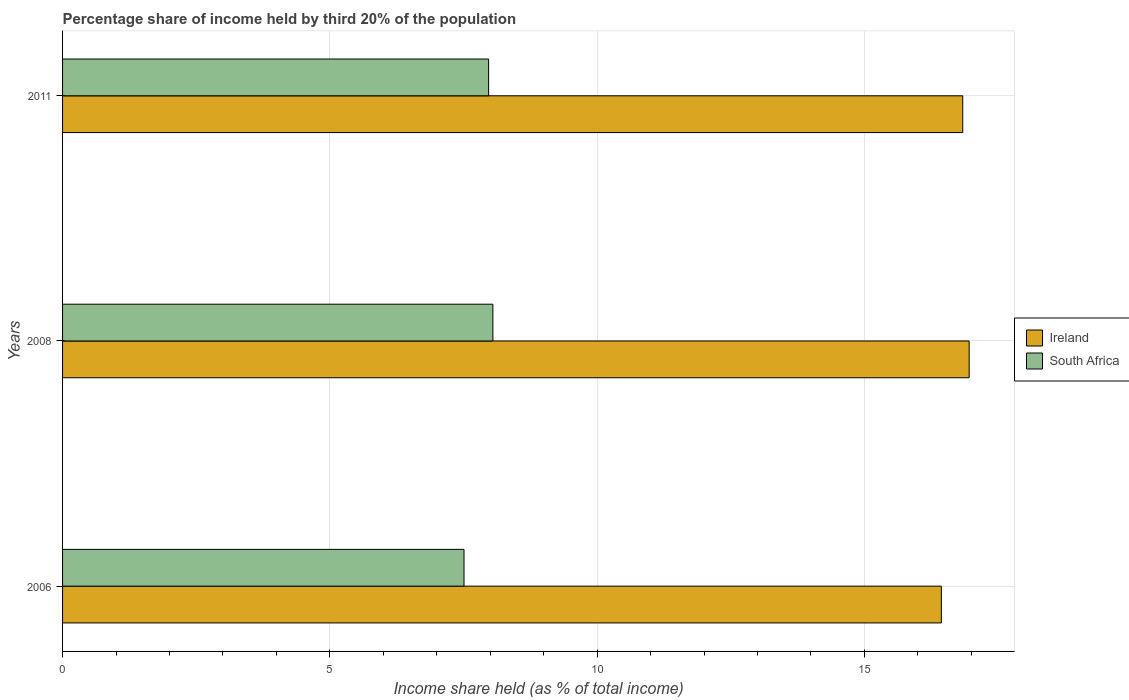How many bars are there on the 1st tick from the top?
Your answer should be compact. 2. How many bars are there on the 2nd tick from the bottom?
Your answer should be compact. 2. In how many cases, is the number of bars for a given year not equal to the number of legend labels?
Make the answer very short. 0. What is the share of income held by third 20% of the population in South Africa in 2008?
Give a very brief answer. 8.05. Across all years, what is the maximum share of income held by third 20% of the population in South Africa?
Keep it short and to the point. 8.05. Across all years, what is the minimum share of income held by third 20% of the population in Ireland?
Provide a succinct answer. 16.44. In which year was the share of income held by third 20% of the population in South Africa maximum?
Your answer should be very brief. 2008. In which year was the share of income held by third 20% of the population in Ireland minimum?
Ensure brevity in your answer.  2006. What is the total share of income held by third 20% of the population in South Africa in the graph?
Provide a succinct answer. 23.53. What is the difference between the share of income held by third 20% of the population in Ireland in 2008 and that in 2011?
Ensure brevity in your answer.  0.12. What is the difference between the share of income held by third 20% of the population in Ireland in 2006 and the share of income held by third 20% of the population in South Africa in 2008?
Your answer should be compact. 8.39. What is the average share of income held by third 20% of the population in South Africa per year?
Provide a succinct answer. 7.84. In the year 2008, what is the difference between the share of income held by third 20% of the population in South Africa and share of income held by third 20% of the population in Ireland?
Make the answer very short. -8.91. What is the ratio of the share of income held by third 20% of the population in Ireland in 2008 to that in 2011?
Make the answer very short. 1.01. What is the difference between the highest and the second highest share of income held by third 20% of the population in Ireland?
Offer a very short reply. 0.12. What is the difference between the highest and the lowest share of income held by third 20% of the population in Ireland?
Your answer should be compact. 0.52. What does the 1st bar from the top in 2006 represents?
Make the answer very short. South Africa. What does the 2nd bar from the bottom in 2008 represents?
Offer a terse response. South Africa. Where does the legend appear in the graph?
Offer a very short reply. Center right. How many legend labels are there?
Offer a terse response. 2. What is the title of the graph?
Offer a very short reply. Percentage share of income held by third 20% of the population. Does "Georgia" appear as one of the legend labels in the graph?
Your answer should be very brief. No. What is the label or title of the X-axis?
Provide a short and direct response. Income share held (as % of total income). What is the Income share held (as % of total income) of Ireland in 2006?
Your response must be concise. 16.44. What is the Income share held (as % of total income) of South Africa in 2006?
Give a very brief answer. 7.51. What is the Income share held (as % of total income) of Ireland in 2008?
Ensure brevity in your answer.  16.96. What is the Income share held (as % of total income) of South Africa in 2008?
Offer a very short reply. 8.05. What is the Income share held (as % of total income) in Ireland in 2011?
Give a very brief answer. 16.84. What is the Income share held (as % of total income) of South Africa in 2011?
Offer a terse response. 7.97. Across all years, what is the maximum Income share held (as % of total income) in Ireland?
Keep it short and to the point. 16.96. Across all years, what is the maximum Income share held (as % of total income) of South Africa?
Provide a short and direct response. 8.05. Across all years, what is the minimum Income share held (as % of total income) of Ireland?
Make the answer very short. 16.44. Across all years, what is the minimum Income share held (as % of total income) in South Africa?
Your answer should be very brief. 7.51. What is the total Income share held (as % of total income) in Ireland in the graph?
Your response must be concise. 50.24. What is the total Income share held (as % of total income) in South Africa in the graph?
Offer a very short reply. 23.53. What is the difference between the Income share held (as % of total income) in Ireland in 2006 and that in 2008?
Ensure brevity in your answer.  -0.52. What is the difference between the Income share held (as % of total income) of South Africa in 2006 and that in 2008?
Ensure brevity in your answer.  -0.54. What is the difference between the Income share held (as % of total income) of South Africa in 2006 and that in 2011?
Ensure brevity in your answer.  -0.46. What is the difference between the Income share held (as % of total income) in Ireland in 2008 and that in 2011?
Provide a succinct answer. 0.12. What is the difference between the Income share held (as % of total income) in South Africa in 2008 and that in 2011?
Keep it short and to the point. 0.08. What is the difference between the Income share held (as % of total income) of Ireland in 2006 and the Income share held (as % of total income) of South Africa in 2008?
Provide a short and direct response. 8.39. What is the difference between the Income share held (as % of total income) of Ireland in 2006 and the Income share held (as % of total income) of South Africa in 2011?
Make the answer very short. 8.47. What is the difference between the Income share held (as % of total income) in Ireland in 2008 and the Income share held (as % of total income) in South Africa in 2011?
Provide a short and direct response. 8.99. What is the average Income share held (as % of total income) in Ireland per year?
Ensure brevity in your answer.  16.75. What is the average Income share held (as % of total income) in South Africa per year?
Make the answer very short. 7.84. In the year 2006, what is the difference between the Income share held (as % of total income) in Ireland and Income share held (as % of total income) in South Africa?
Your answer should be very brief. 8.93. In the year 2008, what is the difference between the Income share held (as % of total income) in Ireland and Income share held (as % of total income) in South Africa?
Keep it short and to the point. 8.91. In the year 2011, what is the difference between the Income share held (as % of total income) in Ireland and Income share held (as % of total income) in South Africa?
Your answer should be very brief. 8.87. What is the ratio of the Income share held (as % of total income) of Ireland in 2006 to that in 2008?
Your answer should be compact. 0.97. What is the ratio of the Income share held (as % of total income) of South Africa in 2006 to that in 2008?
Provide a succinct answer. 0.93. What is the ratio of the Income share held (as % of total income) of Ireland in 2006 to that in 2011?
Your answer should be very brief. 0.98. What is the ratio of the Income share held (as % of total income) of South Africa in 2006 to that in 2011?
Your answer should be compact. 0.94. What is the ratio of the Income share held (as % of total income) of Ireland in 2008 to that in 2011?
Provide a succinct answer. 1.01. What is the ratio of the Income share held (as % of total income) in South Africa in 2008 to that in 2011?
Provide a short and direct response. 1.01. What is the difference between the highest and the second highest Income share held (as % of total income) of Ireland?
Provide a short and direct response. 0.12. What is the difference between the highest and the second highest Income share held (as % of total income) of South Africa?
Your answer should be compact. 0.08. What is the difference between the highest and the lowest Income share held (as % of total income) of Ireland?
Keep it short and to the point. 0.52. What is the difference between the highest and the lowest Income share held (as % of total income) in South Africa?
Your response must be concise. 0.54. 